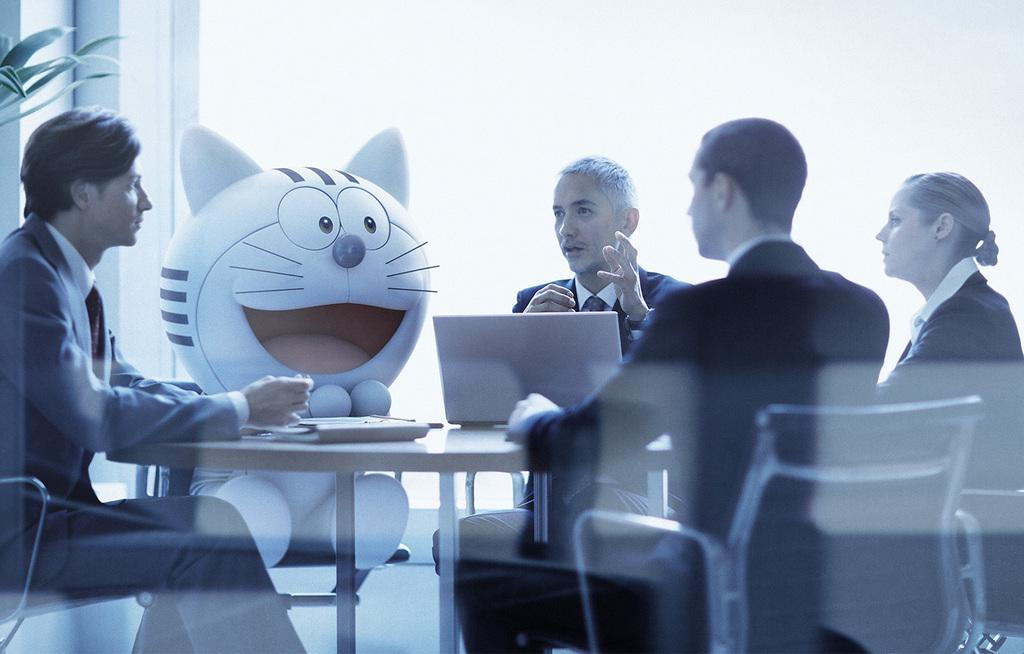How many people are in the image? There are four people in the image: three men and one woman. What are the people doing in the image? The people are sitting on chairs. What object can be seen on the table in the image? There is a laptop on the table. What is placed on one of the chairs in the image? There is a soft toy on a chair. What type of bread is being served to the kitten in the image? There is no kitten or bread present in the image. What prose is being read by the woman in the image? There is no indication in the image that anyone is reading prose. 